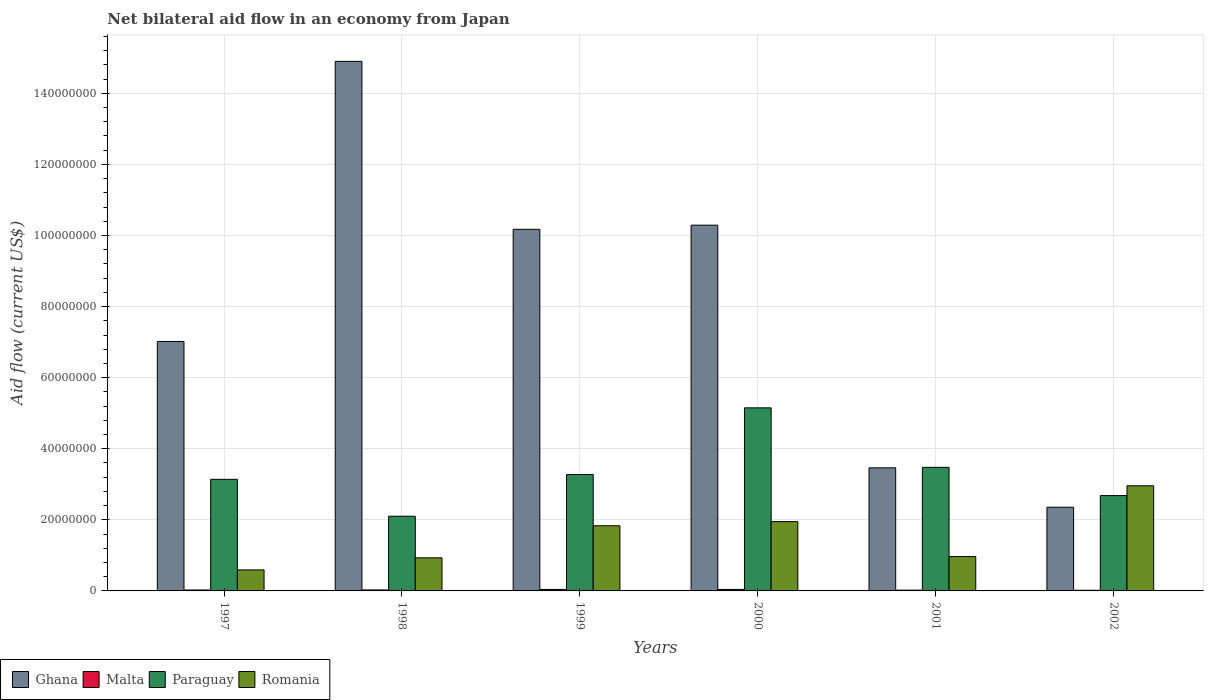How many groups of bars are there?
Offer a very short reply. 6. Are the number of bars per tick equal to the number of legend labels?
Ensure brevity in your answer.  Yes. How many bars are there on the 5th tick from the left?
Give a very brief answer. 4. How many bars are there on the 6th tick from the right?
Give a very brief answer. 4. In how many cases, is the number of bars for a given year not equal to the number of legend labels?
Ensure brevity in your answer.  0. What is the net bilateral aid flow in Paraguay in 2001?
Provide a short and direct response. 3.48e+07. Across all years, what is the maximum net bilateral aid flow in Romania?
Ensure brevity in your answer.  2.96e+07. Across all years, what is the minimum net bilateral aid flow in Ghana?
Ensure brevity in your answer.  2.36e+07. What is the total net bilateral aid flow in Romania in the graph?
Offer a very short reply. 9.23e+07. What is the difference between the net bilateral aid flow in Romania in 1999 and that in 2002?
Ensure brevity in your answer.  -1.12e+07. What is the difference between the net bilateral aid flow in Malta in 1998 and the net bilateral aid flow in Paraguay in 1997?
Give a very brief answer. -3.11e+07. What is the average net bilateral aid flow in Malta per year?
Provide a succinct answer. 2.97e+05. In the year 1997, what is the difference between the net bilateral aid flow in Romania and net bilateral aid flow in Malta?
Offer a very short reply. 5.65e+06. In how many years, is the net bilateral aid flow in Paraguay greater than 152000000 US$?
Offer a very short reply. 0. What is the ratio of the net bilateral aid flow in Romania in 1997 to that in 2000?
Provide a succinct answer. 0.3. Is the difference between the net bilateral aid flow in Romania in 1997 and 1998 greater than the difference between the net bilateral aid flow in Malta in 1997 and 1998?
Provide a short and direct response. No. What is the difference between the highest and the second highest net bilateral aid flow in Romania?
Make the answer very short. 1.01e+07. What is the difference between the highest and the lowest net bilateral aid flow in Romania?
Your answer should be compact. 2.37e+07. Is it the case that in every year, the sum of the net bilateral aid flow in Malta and net bilateral aid flow in Paraguay is greater than the sum of net bilateral aid flow in Romania and net bilateral aid flow in Ghana?
Keep it short and to the point. Yes. What does the 4th bar from the left in 2002 represents?
Your answer should be very brief. Romania. How many bars are there?
Provide a short and direct response. 24. Are all the bars in the graph horizontal?
Your answer should be compact. No. How many years are there in the graph?
Make the answer very short. 6. Are the values on the major ticks of Y-axis written in scientific E-notation?
Offer a very short reply. No. Does the graph contain any zero values?
Your answer should be very brief. No. Does the graph contain grids?
Make the answer very short. Yes. How many legend labels are there?
Offer a very short reply. 4. What is the title of the graph?
Offer a terse response. Net bilateral aid flow in an economy from Japan. Does "OECD members" appear as one of the legend labels in the graph?
Ensure brevity in your answer.  No. What is the label or title of the Y-axis?
Your answer should be very brief. Aid flow (current US$). What is the Aid flow (current US$) of Ghana in 1997?
Your response must be concise. 7.02e+07. What is the Aid flow (current US$) in Malta in 1997?
Your response must be concise. 2.60e+05. What is the Aid flow (current US$) of Paraguay in 1997?
Make the answer very short. 3.14e+07. What is the Aid flow (current US$) of Romania in 1997?
Ensure brevity in your answer.  5.91e+06. What is the Aid flow (current US$) of Ghana in 1998?
Ensure brevity in your answer.  1.49e+08. What is the Aid flow (current US$) of Paraguay in 1998?
Keep it short and to the point. 2.10e+07. What is the Aid flow (current US$) in Romania in 1998?
Offer a very short reply. 9.31e+06. What is the Aid flow (current US$) in Ghana in 1999?
Make the answer very short. 1.02e+08. What is the Aid flow (current US$) of Paraguay in 1999?
Provide a succinct answer. 3.28e+07. What is the Aid flow (current US$) of Romania in 1999?
Your response must be concise. 1.83e+07. What is the Aid flow (current US$) of Ghana in 2000?
Ensure brevity in your answer.  1.03e+08. What is the Aid flow (current US$) in Malta in 2000?
Give a very brief answer. 4.20e+05. What is the Aid flow (current US$) of Paraguay in 2000?
Your answer should be compact. 5.15e+07. What is the Aid flow (current US$) of Romania in 2000?
Provide a succinct answer. 1.95e+07. What is the Aid flow (current US$) of Ghana in 2001?
Keep it short and to the point. 3.46e+07. What is the Aid flow (current US$) of Paraguay in 2001?
Your response must be concise. 3.48e+07. What is the Aid flow (current US$) in Romania in 2001?
Provide a succinct answer. 9.67e+06. What is the Aid flow (current US$) of Ghana in 2002?
Offer a very short reply. 2.36e+07. What is the Aid flow (current US$) of Malta in 2002?
Provide a succinct answer. 1.80e+05. What is the Aid flow (current US$) in Paraguay in 2002?
Give a very brief answer. 2.68e+07. What is the Aid flow (current US$) of Romania in 2002?
Provide a succinct answer. 2.96e+07. Across all years, what is the maximum Aid flow (current US$) in Ghana?
Provide a short and direct response. 1.49e+08. Across all years, what is the maximum Aid flow (current US$) of Malta?
Your response must be concise. 4.20e+05. Across all years, what is the maximum Aid flow (current US$) in Paraguay?
Keep it short and to the point. 5.15e+07. Across all years, what is the maximum Aid flow (current US$) of Romania?
Provide a succinct answer. 2.96e+07. Across all years, what is the minimum Aid flow (current US$) in Ghana?
Your answer should be very brief. 2.36e+07. Across all years, what is the minimum Aid flow (current US$) of Malta?
Make the answer very short. 1.80e+05. Across all years, what is the minimum Aid flow (current US$) in Paraguay?
Offer a very short reply. 2.10e+07. Across all years, what is the minimum Aid flow (current US$) of Romania?
Your answer should be very brief. 5.91e+06. What is the total Aid flow (current US$) in Ghana in the graph?
Your answer should be compact. 4.82e+08. What is the total Aid flow (current US$) of Malta in the graph?
Make the answer very short. 1.78e+06. What is the total Aid flow (current US$) in Paraguay in the graph?
Ensure brevity in your answer.  1.98e+08. What is the total Aid flow (current US$) of Romania in the graph?
Provide a succinct answer. 9.23e+07. What is the difference between the Aid flow (current US$) of Ghana in 1997 and that in 1998?
Offer a terse response. -7.88e+07. What is the difference between the Aid flow (current US$) in Paraguay in 1997 and that in 1998?
Offer a terse response. 1.04e+07. What is the difference between the Aid flow (current US$) in Romania in 1997 and that in 1998?
Give a very brief answer. -3.40e+06. What is the difference between the Aid flow (current US$) in Ghana in 1997 and that in 1999?
Your response must be concise. -3.16e+07. What is the difference between the Aid flow (current US$) of Malta in 1997 and that in 1999?
Give a very brief answer. -1.60e+05. What is the difference between the Aid flow (current US$) in Paraguay in 1997 and that in 1999?
Make the answer very short. -1.36e+06. What is the difference between the Aid flow (current US$) in Romania in 1997 and that in 1999?
Keep it short and to the point. -1.24e+07. What is the difference between the Aid flow (current US$) of Ghana in 1997 and that in 2000?
Give a very brief answer. -3.27e+07. What is the difference between the Aid flow (current US$) of Malta in 1997 and that in 2000?
Your answer should be compact. -1.60e+05. What is the difference between the Aid flow (current US$) of Paraguay in 1997 and that in 2000?
Your answer should be compact. -2.01e+07. What is the difference between the Aid flow (current US$) in Romania in 1997 and that in 2000?
Offer a very short reply. -1.36e+07. What is the difference between the Aid flow (current US$) in Ghana in 1997 and that in 2001?
Your answer should be very brief. 3.56e+07. What is the difference between the Aid flow (current US$) in Paraguay in 1997 and that in 2001?
Provide a short and direct response. -3.37e+06. What is the difference between the Aid flow (current US$) of Romania in 1997 and that in 2001?
Your answer should be compact. -3.76e+06. What is the difference between the Aid flow (current US$) of Ghana in 1997 and that in 2002?
Offer a very short reply. 4.66e+07. What is the difference between the Aid flow (current US$) in Malta in 1997 and that in 2002?
Provide a succinct answer. 8.00e+04. What is the difference between the Aid flow (current US$) of Paraguay in 1997 and that in 2002?
Provide a succinct answer. 4.58e+06. What is the difference between the Aid flow (current US$) in Romania in 1997 and that in 2002?
Keep it short and to the point. -2.37e+07. What is the difference between the Aid flow (current US$) of Ghana in 1998 and that in 1999?
Offer a terse response. 4.72e+07. What is the difference between the Aid flow (current US$) in Malta in 1998 and that in 1999?
Ensure brevity in your answer.  -1.40e+05. What is the difference between the Aid flow (current US$) in Paraguay in 1998 and that in 1999?
Your response must be concise. -1.17e+07. What is the difference between the Aid flow (current US$) in Romania in 1998 and that in 1999?
Provide a succinct answer. -9.03e+06. What is the difference between the Aid flow (current US$) in Ghana in 1998 and that in 2000?
Offer a terse response. 4.61e+07. What is the difference between the Aid flow (current US$) of Malta in 1998 and that in 2000?
Keep it short and to the point. -1.40e+05. What is the difference between the Aid flow (current US$) in Paraguay in 1998 and that in 2000?
Your response must be concise. -3.05e+07. What is the difference between the Aid flow (current US$) of Romania in 1998 and that in 2000?
Provide a short and direct response. -1.02e+07. What is the difference between the Aid flow (current US$) of Ghana in 1998 and that in 2001?
Ensure brevity in your answer.  1.14e+08. What is the difference between the Aid flow (current US$) in Malta in 1998 and that in 2001?
Ensure brevity in your answer.  6.00e+04. What is the difference between the Aid flow (current US$) of Paraguay in 1998 and that in 2001?
Give a very brief answer. -1.38e+07. What is the difference between the Aid flow (current US$) of Romania in 1998 and that in 2001?
Your answer should be very brief. -3.60e+05. What is the difference between the Aid flow (current US$) in Ghana in 1998 and that in 2002?
Your answer should be compact. 1.25e+08. What is the difference between the Aid flow (current US$) of Malta in 1998 and that in 2002?
Offer a terse response. 1.00e+05. What is the difference between the Aid flow (current US$) in Paraguay in 1998 and that in 2002?
Ensure brevity in your answer.  -5.80e+06. What is the difference between the Aid flow (current US$) of Romania in 1998 and that in 2002?
Make the answer very short. -2.03e+07. What is the difference between the Aid flow (current US$) of Ghana in 1999 and that in 2000?
Your response must be concise. -1.16e+06. What is the difference between the Aid flow (current US$) in Malta in 1999 and that in 2000?
Ensure brevity in your answer.  0. What is the difference between the Aid flow (current US$) of Paraguay in 1999 and that in 2000?
Offer a terse response. -1.88e+07. What is the difference between the Aid flow (current US$) in Romania in 1999 and that in 2000?
Your answer should be compact. -1.16e+06. What is the difference between the Aid flow (current US$) of Ghana in 1999 and that in 2001?
Provide a succinct answer. 6.71e+07. What is the difference between the Aid flow (current US$) of Malta in 1999 and that in 2001?
Offer a very short reply. 2.00e+05. What is the difference between the Aid flow (current US$) of Paraguay in 1999 and that in 2001?
Make the answer very short. -2.01e+06. What is the difference between the Aid flow (current US$) of Romania in 1999 and that in 2001?
Give a very brief answer. 8.67e+06. What is the difference between the Aid flow (current US$) of Ghana in 1999 and that in 2002?
Provide a short and direct response. 7.82e+07. What is the difference between the Aid flow (current US$) in Paraguay in 1999 and that in 2002?
Your answer should be compact. 5.94e+06. What is the difference between the Aid flow (current US$) of Romania in 1999 and that in 2002?
Your answer should be very brief. -1.12e+07. What is the difference between the Aid flow (current US$) of Ghana in 2000 and that in 2001?
Ensure brevity in your answer.  6.83e+07. What is the difference between the Aid flow (current US$) of Paraguay in 2000 and that in 2001?
Keep it short and to the point. 1.67e+07. What is the difference between the Aid flow (current US$) in Romania in 2000 and that in 2001?
Offer a very short reply. 9.83e+06. What is the difference between the Aid flow (current US$) in Ghana in 2000 and that in 2002?
Keep it short and to the point. 7.94e+07. What is the difference between the Aid flow (current US$) of Paraguay in 2000 and that in 2002?
Offer a very short reply. 2.47e+07. What is the difference between the Aid flow (current US$) of Romania in 2000 and that in 2002?
Give a very brief answer. -1.01e+07. What is the difference between the Aid flow (current US$) of Ghana in 2001 and that in 2002?
Your answer should be compact. 1.11e+07. What is the difference between the Aid flow (current US$) in Paraguay in 2001 and that in 2002?
Your answer should be very brief. 7.95e+06. What is the difference between the Aid flow (current US$) of Romania in 2001 and that in 2002?
Offer a very short reply. -1.99e+07. What is the difference between the Aid flow (current US$) of Ghana in 1997 and the Aid flow (current US$) of Malta in 1998?
Provide a short and direct response. 6.99e+07. What is the difference between the Aid flow (current US$) in Ghana in 1997 and the Aid flow (current US$) in Paraguay in 1998?
Give a very brief answer. 4.92e+07. What is the difference between the Aid flow (current US$) of Ghana in 1997 and the Aid flow (current US$) of Romania in 1998?
Make the answer very short. 6.09e+07. What is the difference between the Aid flow (current US$) of Malta in 1997 and the Aid flow (current US$) of Paraguay in 1998?
Make the answer very short. -2.08e+07. What is the difference between the Aid flow (current US$) of Malta in 1997 and the Aid flow (current US$) of Romania in 1998?
Keep it short and to the point. -9.05e+06. What is the difference between the Aid flow (current US$) of Paraguay in 1997 and the Aid flow (current US$) of Romania in 1998?
Your answer should be very brief. 2.21e+07. What is the difference between the Aid flow (current US$) in Ghana in 1997 and the Aid flow (current US$) in Malta in 1999?
Provide a succinct answer. 6.98e+07. What is the difference between the Aid flow (current US$) of Ghana in 1997 and the Aid flow (current US$) of Paraguay in 1999?
Keep it short and to the point. 3.74e+07. What is the difference between the Aid flow (current US$) in Ghana in 1997 and the Aid flow (current US$) in Romania in 1999?
Give a very brief answer. 5.18e+07. What is the difference between the Aid flow (current US$) in Malta in 1997 and the Aid flow (current US$) in Paraguay in 1999?
Keep it short and to the point. -3.25e+07. What is the difference between the Aid flow (current US$) of Malta in 1997 and the Aid flow (current US$) of Romania in 1999?
Offer a terse response. -1.81e+07. What is the difference between the Aid flow (current US$) in Paraguay in 1997 and the Aid flow (current US$) in Romania in 1999?
Your answer should be very brief. 1.31e+07. What is the difference between the Aid flow (current US$) in Ghana in 1997 and the Aid flow (current US$) in Malta in 2000?
Provide a succinct answer. 6.98e+07. What is the difference between the Aid flow (current US$) of Ghana in 1997 and the Aid flow (current US$) of Paraguay in 2000?
Your answer should be compact. 1.87e+07. What is the difference between the Aid flow (current US$) in Ghana in 1997 and the Aid flow (current US$) in Romania in 2000?
Your answer should be compact. 5.07e+07. What is the difference between the Aid flow (current US$) in Malta in 1997 and the Aid flow (current US$) in Paraguay in 2000?
Your answer should be compact. -5.12e+07. What is the difference between the Aid flow (current US$) in Malta in 1997 and the Aid flow (current US$) in Romania in 2000?
Keep it short and to the point. -1.92e+07. What is the difference between the Aid flow (current US$) of Paraguay in 1997 and the Aid flow (current US$) of Romania in 2000?
Ensure brevity in your answer.  1.19e+07. What is the difference between the Aid flow (current US$) in Ghana in 1997 and the Aid flow (current US$) in Malta in 2001?
Your answer should be compact. 7.00e+07. What is the difference between the Aid flow (current US$) in Ghana in 1997 and the Aid flow (current US$) in Paraguay in 2001?
Your answer should be compact. 3.54e+07. What is the difference between the Aid flow (current US$) in Ghana in 1997 and the Aid flow (current US$) in Romania in 2001?
Ensure brevity in your answer.  6.05e+07. What is the difference between the Aid flow (current US$) in Malta in 1997 and the Aid flow (current US$) in Paraguay in 2001?
Offer a terse response. -3.45e+07. What is the difference between the Aid flow (current US$) in Malta in 1997 and the Aid flow (current US$) in Romania in 2001?
Give a very brief answer. -9.41e+06. What is the difference between the Aid flow (current US$) of Paraguay in 1997 and the Aid flow (current US$) of Romania in 2001?
Your response must be concise. 2.17e+07. What is the difference between the Aid flow (current US$) of Ghana in 1997 and the Aid flow (current US$) of Malta in 2002?
Your answer should be compact. 7.00e+07. What is the difference between the Aid flow (current US$) of Ghana in 1997 and the Aid flow (current US$) of Paraguay in 2002?
Offer a terse response. 4.34e+07. What is the difference between the Aid flow (current US$) in Ghana in 1997 and the Aid flow (current US$) in Romania in 2002?
Offer a very short reply. 4.06e+07. What is the difference between the Aid flow (current US$) in Malta in 1997 and the Aid flow (current US$) in Paraguay in 2002?
Provide a short and direct response. -2.66e+07. What is the difference between the Aid flow (current US$) of Malta in 1997 and the Aid flow (current US$) of Romania in 2002?
Your response must be concise. -2.93e+07. What is the difference between the Aid flow (current US$) of Paraguay in 1997 and the Aid flow (current US$) of Romania in 2002?
Keep it short and to the point. 1.82e+06. What is the difference between the Aid flow (current US$) in Ghana in 1998 and the Aid flow (current US$) in Malta in 1999?
Your answer should be compact. 1.49e+08. What is the difference between the Aid flow (current US$) of Ghana in 1998 and the Aid flow (current US$) of Paraguay in 1999?
Your response must be concise. 1.16e+08. What is the difference between the Aid flow (current US$) in Ghana in 1998 and the Aid flow (current US$) in Romania in 1999?
Your answer should be very brief. 1.31e+08. What is the difference between the Aid flow (current US$) of Malta in 1998 and the Aid flow (current US$) of Paraguay in 1999?
Give a very brief answer. -3.25e+07. What is the difference between the Aid flow (current US$) in Malta in 1998 and the Aid flow (current US$) in Romania in 1999?
Make the answer very short. -1.81e+07. What is the difference between the Aid flow (current US$) in Paraguay in 1998 and the Aid flow (current US$) in Romania in 1999?
Give a very brief answer. 2.68e+06. What is the difference between the Aid flow (current US$) of Ghana in 1998 and the Aid flow (current US$) of Malta in 2000?
Provide a succinct answer. 1.49e+08. What is the difference between the Aid flow (current US$) in Ghana in 1998 and the Aid flow (current US$) in Paraguay in 2000?
Give a very brief answer. 9.75e+07. What is the difference between the Aid flow (current US$) of Ghana in 1998 and the Aid flow (current US$) of Romania in 2000?
Keep it short and to the point. 1.30e+08. What is the difference between the Aid flow (current US$) of Malta in 1998 and the Aid flow (current US$) of Paraguay in 2000?
Your answer should be very brief. -5.12e+07. What is the difference between the Aid flow (current US$) in Malta in 1998 and the Aid flow (current US$) in Romania in 2000?
Make the answer very short. -1.92e+07. What is the difference between the Aid flow (current US$) in Paraguay in 1998 and the Aid flow (current US$) in Romania in 2000?
Your response must be concise. 1.52e+06. What is the difference between the Aid flow (current US$) in Ghana in 1998 and the Aid flow (current US$) in Malta in 2001?
Your answer should be very brief. 1.49e+08. What is the difference between the Aid flow (current US$) in Ghana in 1998 and the Aid flow (current US$) in Paraguay in 2001?
Your answer should be very brief. 1.14e+08. What is the difference between the Aid flow (current US$) in Ghana in 1998 and the Aid flow (current US$) in Romania in 2001?
Give a very brief answer. 1.39e+08. What is the difference between the Aid flow (current US$) in Malta in 1998 and the Aid flow (current US$) in Paraguay in 2001?
Offer a terse response. -3.45e+07. What is the difference between the Aid flow (current US$) in Malta in 1998 and the Aid flow (current US$) in Romania in 2001?
Your answer should be compact. -9.39e+06. What is the difference between the Aid flow (current US$) in Paraguay in 1998 and the Aid flow (current US$) in Romania in 2001?
Give a very brief answer. 1.14e+07. What is the difference between the Aid flow (current US$) of Ghana in 1998 and the Aid flow (current US$) of Malta in 2002?
Your answer should be compact. 1.49e+08. What is the difference between the Aid flow (current US$) in Ghana in 1998 and the Aid flow (current US$) in Paraguay in 2002?
Provide a short and direct response. 1.22e+08. What is the difference between the Aid flow (current US$) of Ghana in 1998 and the Aid flow (current US$) of Romania in 2002?
Ensure brevity in your answer.  1.19e+08. What is the difference between the Aid flow (current US$) of Malta in 1998 and the Aid flow (current US$) of Paraguay in 2002?
Your answer should be compact. -2.65e+07. What is the difference between the Aid flow (current US$) of Malta in 1998 and the Aid flow (current US$) of Romania in 2002?
Keep it short and to the point. -2.93e+07. What is the difference between the Aid flow (current US$) of Paraguay in 1998 and the Aid flow (current US$) of Romania in 2002?
Your answer should be compact. -8.56e+06. What is the difference between the Aid flow (current US$) in Ghana in 1999 and the Aid flow (current US$) in Malta in 2000?
Offer a terse response. 1.01e+08. What is the difference between the Aid flow (current US$) in Ghana in 1999 and the Aid flow (current US$) in Paraguay in 2000?
Provide a short and direct response. 5.02e+07. What is the difference between the Aid flow (current US$) in Ghana in 1999 and the Aid flow (current US$) in Romania in 2000?
Give a very brief answer. 8.22e+07. What is the difference between the Aid flow (current US$) in Malta in 1999 and the Aid flow (current US$) in Paraguay in 2000?
Your response must be concise. -5.11e+07. What is the difference between the Aid flow (current US$) in Malta in 1999 and the Aid flow (current US$) in Romania in 2000?
Give a very brief answer. -1.91e+07. What is the difference between the Aid flow (current US$) of Paraguay in 1999 and the Aid flow (current US$) of Romania in 2000?
Ensure brevity in your answer.  1.33e+07. What is the difference between the Aid flow (current US$) of Ghana in 1999 and the Aid flow (current US$) of Malta in 2001?
Make the answer very short. 1.02e+08. What is the difference between the Aid flow (current US$) in Ghana in 1999 and the Aid flow (current US$) in Paraguay in 2001?
Ensure brevity in your answer.  6.70e+07. What is the difference between the Aid flow (current US$) of Ghana in 1999 and the Aid flow (current US$) of Romania in 2001?
Keep it short and to the point. 9.21e+07. What is the difference between the Aid flow (current US$) of Malta in 1999 and the Aid flow (current US$) of Paraguay in 2001?
Your answer should be compact. -3.44e+07. What is the difference between the Aid flow (current US$) of Malta in 1999 and the Aid flow (current US$) of Romania in 2001?
Give a very brief answer. -9.25e+06. What is the difference between the Aid flow (current US$) of Paraguay in 1999 and the Aid flow (current US$) of Romania in 2001?
Provide a short and direct response. 2.31e+07. What is the difference between the Aid flow (current US$) of Ghana in 1999 and the Aid flow (current US$) of Malta in 2002?
Your response must be concise. 1.02e+08. What is the difference between the Aid flow (current US$) in Ghana in 1999 and the Aid flow (current US$) in Paraguay in 2002?
Offer a very short reply. 7.49e+07. What is the difference between the Aid flow (current US$) in Ghana in 1999 and the Aid flow (current US$) in Romania in 2002?
Offer a very short reply. 7.22e+07. What is the difference between the Aid flow (current US$) in Malta in 1999 and the Aid flow (current US$) in Paraguay in 2002?
Offer a very short reply. -2.64e+07. What is the difference between the Aid flow (current US$) of Malta in 1999 and the Aid flow (current US$) of Romania in 2002?
Offer a terse response. -2.92e+07. What is the difference between the Aid flow (current US$) of Paraguay in 1999 and the Aid flow (current US$) of Romania in 2002?
Your response must be concise. 3.18e+06. What is the difference between the Aid flow (current US$) in Ghana in 2000 and the Aid flow (current US$) in Malta in 2001?
Your answer should be very brief. 1.03e+08. What is the difference between the Aid flow (current US$) in Ghana in 2000 and the Aid flow (current US$) in Paraguay in 2001?
Keep it short and to the point. 6.81e+07. What is the difference between the Aid flow (current US$) of Ghana in 2000 and the Aid flow (current US$) of Romania in 2001?
Ensure brevity in your answer.  9.32e+07. What is the difference between the Aid flow (current US$) in Malta in 2000 and the Aid flow (current US$) in Paraguay in 2001?
Give a very brief answer. -3.44e+07. What is the difference between the Aid flow (current US$) of Malta in 2000 and the Aid flow (current US$) of Romania in 2001?
Your response must be concise. -9.25e+06. What is the difference between the Aid flow (current US$) in Paraguay in 2000 and the Aid flow (current US$) in Romania in 2001?
Ensure brevity in your answer.  4.18e+07. What is the difference between the Aid flow (current US$) in Ghana in 2000 and the Aid flow (current US$) in Malta in 2002?
Ensure brevity in your answer.  1.03e+08. What is the difference between the Aid flow (current US$) in Ghana in 2000 and the Aid flow (current US$) in Paraguay in 2002?
Provide a short and direct response. 7.61e+07. What is the difference between the Aid flow (current US$) of Ghana in 2000 and the Aid flow (current US$) of Romania in 2002?
Offer a terse response. 7.33e+07. What is the difference between the Aid flow (current US$) of Malta in 2000 and the Aid flow (current US$) of Paraguay in 2002?
Provide a succinct answer. -2.64e+07. What is the difference between the Aid flow (current US$) in Malta in 2000 and the Aid flow (current US$) in Romania in 2002?
Give a very brief answer. -2.92e+07. What is the difference between the Aid flow (current US$) of Paraguay in 2000 and the Aid flow (current US$) of Romania in 2002?
Make the answer very short. 2.19e+07. What is the difference between the Aid flow (current US$) in Ghana in 2001 and the Aid flow (current US$) in Malta in 2002?
Ensure brevity in your answer.  3.44e+07. What is the difference between the Aid flow (current US$) in Ghana in 2001 and the Aid flow (current US$) in Paraguay in 2002?
Offer a very short reply. 7.81e+06. What is the difference between the Aid flow (current US$) of Ghana in 2001 and the Aid flow (current US$) of Romania in 2002?
Make the answer very short. 5.05e+06. What is the difference between the Aid flow (current US$) of Malta in 2001 and the Aid flow (current US$) of Paraguay in 2002?
Offer a terse response. -2.66e+07. What is the difference between the Aid flow (current US$) of Malta in 2001 and the Aid flow (current US$) of Romania in 2002?
Your answer should be compact. -2.94e+07. What is the difference between the Aid flow (current US$) in Paraguay in 2001 and the Aid flow (current US$) in Romania in 2002?
Your answer should be compact. 5.19e+06. What is the average Aid flow (current US$) of Ghana per year?
Your answer should be very brief. 8.03e+07. What is the average Aid flow (current US$) in Malta per year?
Your answer should be compact. 2.97e+05. What is the average Aid flow (current US$) in Paraguay per year?
Keep it short and to the point. 3.30e+07. What is the average Aid flow (current US$) in Romania per year?
Make the answer very short. 1.54e+07. In the year 1997, what is the difference between the Aid flow (current US$) in Ghana and Aid flow (current US$) in Malta?
Keep it short and to the point. 6.99e+07. In the year 1997, what is the difference between the Aid flow (current US$) of Ghana and Aid flow (current US$) of Paraguay?
Ensure brevity in your answer.  3.88e+07. In the year 1997, what is the difference between the Aid flow (current US$) of Ghana and Aid flow (current US$) of Romania?
Provide a succinct answer. 6.43e+07. In the year 1997, what is the difference between the Aid flow (current US$) in Malta and Aid flow (current US$) in Paraguay?
Provide a succinct answer. -3.11e+07. In the year 1997, what is the difference between the Aid flow (current US$) of Malta and Aid flow (current US$) of Romania?
Your answer should be very brief. -5.65e+06. In the year 1997, what is the difference between the Aid flow (current US$) of Paraguay and Aid flow (current US$) of Romania?
Keep it short and to the point. 2.55e+07. In the year 1998, what is the difference between the Aid flow (current US$) in Ghana and Aid flow (current US$) in Malta?
Your response must be concise. 1.49e+08. In the year 1998, what is the difference between the Aid flow (current US$) in Ghana and Aid flow (current US$) in Paraguay?
Provide a succinct answer. 1.28e+08. In the year 1998, what is the difference between the Aid flow (current US$) of Ghana and Aid flow (current US$) of Romania?
Keep it short and to the point. 1.40e+08. In the year 1998, what is the difference between the Aid flow (current US$) of Malta and Aid flow (current US$) of Paraguay?
Provide a succinct answer. -2.07e+07. In the year 1998, what is the difference between the Aid flow (current US$) of Malta and Aid flow (current US$) of Romania?
Offer a very short reply. -9.03e+06. In the year 1998, what is the difference between the Aid flow (current US$) of Paraguay and Aid flow (current US$) of Romania?
Give a very brief answer. 1.17e+07. In the year 1999, what is the difference between the Aid flow (current US$) of Ghana and Aid flow (current US$) of Malta?
Make the answer very short. 1.01e+08. In the year 1999, what is the difference between the Aid flow (current US$) in Ghana and Aid flow (current US$) in Paraguay?
Provide a succinct answer. 6.90e+07. In the year 1999, what is the difference between the Aid flow (current US$) in Ghana and Aid flow (current US$) in Romania?
Your answer should be very brief. 8.34e+07. In the year 1999, what is the difference between the Aid flow (current US$) in Malta and Aid flow (current US$) in Paraguay?
Your answer should be very brief. -3.23e+07. In the year 1999, what is the difference between the Aid flow (current US$) in Malta and Aid flow (current US$) in Romania?
Provide a short and direct response. -1.79e+07. In the year 1999, what is the difference between the Aid flow (current US$) in Paraguay and Aid flow (current US$) in Romania?
Provide a succinct answer. 1.44e+07. In the year 2000, what is the difference between the Aid flow (current US$) in Ghana and Aid flow (current US$) in Malta?
Your answer should be compact. 1.02e+08. In the year 2000, what is the difference between the Aid flow (current US$) in Ghana and Aid flow (current US$) in Paraguay?
Offer a terse response. 5.14e+07. In the year 2000, what is the difference between the Aid flow (current US$) of Ghana and Aid flow (current US$) of Romania?
Keep it short and to the point. 8.34e+07. In the year 2000, what is the difference between the Aid flow (current US$) of Malta and Aid flow (current US$) of Paraguay?
Your response must be concise. -5.11e+07. In the year 2000, what is the difference between the Aid flow (current US$) of Malta and Aid flow (current US$) of Romania?
Provide a succinct answer. -1.91e+07. In the year 2000, what is the difference between the Aid flow (current US$) in Paraguay and Aid flow (current US$) in Romania?
Provide a short and direct response. 3.20e+07. In the year 2001, what is the difference between the Aid flow (current US$) of Ghana and Aid flow (current US$) of Malta?
Your answer should be very brief. 3.44e+07. In the year 2001, what is the difference between the Aid flow (current US$) in Ghana and Aid flow (current US$) in Romania?
Your answer should be very brief. 2.50e+07. In the year 2001, what is the difference between the Aid flow (current US$) of Malta and Aid flow (current US$) of Paraguay?
Ensure brevity in your answer.  -3.46e+07. In the year 2001, what is the difference between the Aid flow (current US$) in Malta and Aid flow (current US$) in Romania?
Make the answer very short. -9.45e+06. In the year 2001, what is the difference between the Aid flow (current US$) of Paraguay and Aid flow (current US$) of Romania?
Offer a terse response. 2.51e+07. In the year 2002, what is the difference between the Aid flow (current US$) of Ghana and Aid flow (current US$) of Malta?
Make the answer very short. 2.34e+07. In the year 2002, what is the difference between the Aid flow (current US$) of Ghana and Aid flow (current US$) of Paraguay?
Offer a very short reply. -3.27e+06. In the year 2002, what is the difference between the Aid flow (current US$) of Ghana and Aid flow (current US$) of Romania?
Give a very brief answer. -6.03e+06. In the year 2002, what is the difference between the Aid flow (current US$) in Malta and Aid flow (current US$) in Paraguay?
Your answer should be compact. -2.66e+07. In the year 2002, what is the difference between the Aid flow (current US$) in Malta and Aid flow (current US$) in Romania?
Ensure brevity in your answer.  -2.94e+07. In the year 2002, what is the difference between the Aid flow (current US$) in Paraguay and Aid flow (current US$) in Romania?
Offer a terse response. -2.76e+06. What is the ratio of the Aid flow (current US$) of Ghana in 1997 to that in 1998?
Give a very brief answer. 0.47. What is the ratio of the Aid flow (current US$) of Paraguay in 1997 to that in 1998?
Your answer should be compact. 1.49. What is the ratio of the Aid flow (current US$) of Romania in 1997 to that in 1998?
Make the answer very short. 0.63. What is the ratio of the Aid flow (current US$) of Ghana in 1997 to that in 1999?
Your answer should be very brief. 0.69. What is the ratio of the Aid flow (current US$) of Malta in 1997 to that in 1999?
Your answer should be compact. 0.62. What is the ratio of the Aid flow (current US$) in Paraguay in 1997 to that in 1999?
Keep it short and to the point. 0.96. What is the ratio of the Aid flow (current US$) in Romania in 1997 to that in 1999?
Your answer should be very brief. 0.32. What is the ratio of the Aid flow (current US$) of Ghana in 1997 to that in 2000?
Your answer should be compact. 0.68. What is the ratio of the Aid flow (current US$) in Malta in 1997 to that in 2000?
Your response must be concise. 0.62. What is the ratio of the Aid flow (current US$) in Paraguay in 1997 to that in 2000?
Provide a short and direct response. 0.61. What is the ratio of the Aid flow (current US$) in Romania in 1997 to that in 2000?
Give a very brief answer. 0.3. What is the ratio of the Aid flow (current US$) of Ghana in 1997 to that in 2001?
Give a very brief answer. 2.03. What is the ratio of the Aid flow (current US$) of Malta in 1997 to that in 2001?
Your response must be concise. 1.18. What is the ratio of the Aid flow (current US$) in Paraguay in 1997 to that in 2001?
Your response must be concise. 0.9. What is the ratio of the Aid flow (current US$) in Romania in 1997 to that in 2001?
Ensure brevity in your answer.  0.61. What is the ratio of the Aid flow (current US$) of Ghana in 1997 to that in 2002?
Keep it short and to the point. 2.98. What is the ratio of the Aid flow (current US$) in Malta in 1997 to that in 2002?
Your response must be concise. 1.44. What is the ratio of the Aid flow (current US$) in Paraguay in 1997 to that in 2002?
Provide a succinct answer. 1.17. What is the ratio of the Aid flow (current US$) of Romania in 1997 to that in 2002?
Give a very brief answer. 0.2. What is the ratio of the Aid flow (current US$) of Ghana in 1998 to that in 1999?
Your answer should be very brief. 1.46. What is the ratio of the Aid flow (current US$) of Malta in 1998 to that in 1999?
Your response must be concise. 0.67. What is the ratio of the Aid flow (current US$) in Paraguay in 1998 to that in 1999?
Ensure brevity in your answer.  0.64. What is the ratio of the Aid flow (current US$) in Romania in 1998 to that in 1999?
Give a very brief answer. 0.51. What is the ratio of the Aid flow (current US$) of Ghana in 1998 to that in 2000?
Keep it short and to the point. 1.45. What is the ratio of the Aid flow (current US$) in Paraguay in 1998 to that in 2000?
Give a very brief answer. 0.41. What is the ratio of the Aid flow (current US$) in Romania in 1998 to that in 2000?
Provide a short and direct response. 0.48. What is the ratio of the Aid flow (current US$) in Ghana in 1998 to that in 2001?
Provide a short and direct response. 4.3. What is the ratio of the Aid flow (current US$) of Malta in 1998 to that in 2001?
Your answer should be compact. 1.27. What is the ratio of the Aid flow (current US$) of Paraguay in 1998 to that in 2001?
Give a very brief answer. 0.6. What is the ratio of the Aid flow (current US$) in Romania in 1998 to that in 2001?
Provide a succinct answer. 0.96. What is the ratio of the Aid flow (current US$) in Ghana in 1998 to that in 2002?
Provide a short and direct response. 6.33. What is the ratio of the Aid flow (current US$) in Malta in 1998 to that in 2002?
Keep it short and to the point. 1.56. What is the ratio of the Aid flow (current US$) in Paraguay in 1998 to that in 2002?
Ensure brevity in your answer.  0.78. What is the ratio of the Aid flow (current US$) of Romania in 1998 to that in 2002?
Your answer should be very brief. 0.31. What is the ratio of the Aid flow (current US$) in Ghana in 1999 to that in 2000?
Ensure brevity in your answer.  0.99. What is the ratio of the Aid flow (current US$) of Paraguay in 1999 to that in 2000?
Keep it short and to the point. 0.64. What is the ratio of the Aid flow (current US$) of Romania in 1999 to that in 2000?
Provide a short and direct response. 0.94. What is the ratio of the Aid flow (current US$) in Ghana in 1999 to that in 2001?
Offer a very short reply. 2.94. What is the ratio of the Aid flow (current US$) in Malta in 1999 to that in 2001?
Offer a very short reply. 1.91. What is the ratio of the Aid flow (current US$) of Paraguay in 1999 to that in 2001?
Keep it short and to the point. 0.94. What is the ratio of the Aid flow (current US$) of Romania in 1999 to that in 2001?
Provide a short and direct response. 1.9. What is the ratio of the Aid flow (current US$) of Ghana in 1999 to that in 2002?
Your answer should be compact. 4.32. What is the ratio of the Aid flow (current US$) in Malta in 1999 to that in 2002?
Your answer should be very brief. 2.33. What is the ratio of the Aid flow (current US$) in Paraguay in 1999 to that in 2002?
Offer a very short reply. 1.22. What is the ratio of the Aid flow (current US$) of Romania in 1999 to that in 2002?
Your response must be concise. 0.62. What is the ratio of the Aid flow (current US$) of Ghana in 2000 to that in 2001?
Ensure brevity in your answer.  2.97. What is the ratio of the Aid flow (current US$) in Malta in 2000 to that in 2001?
Provide a succinct answer. 1.91. What is the ratio of the Aid flow (current US$) of Paraguay in 2000 to that in 2001?
Keep it short and to the point. 1.48. What is the ratio of the Aid flow (current US$) in Romania in 2000 to that in 2001?
Provide a short and direct response. 2.02. What is the ratio of the Aid flow (current US$) of Ghana in 2000 to that in 2002?
Keep it short and to the point. 4.37. What is the ratio of the Aid flow (current US$) of Malta in 2000 to that in 2002?
Ensure brevity in your answer.  2.33. What is the ratio of the Aid flow (current US$) in Paraguay in 2000 to that in 2002?
Offer a terse response. 1.92. What is the ratio of the Aid flow (current US$) in Romania in 2000 to that in 2002?
Provide a succinct answer. 0.66. What is the ratio of the Aid flow (current US$) in Ghana in 2001 to that in 2002?
Offer a terse response. 1.47. What is the ratio of the Aid flow (current US$) of Malta in 2001 to that in 2002?
Offer a terse response. 1.22. What is the ratio of the Aid flow (current US$) of Paraguay in 2001 to that in 2002?
Offer a very short reply. 1.3. What is the ratio of the Aid flow (current US$) in Romania in 2001 to that in 2002?
Provide a short and direct response. 0.33. What is the difference between the highest and the second highest Aid flow (current US$) in Ghana?
Your answer should be very brief. 4.61e+07. What is the difference between the highest and the second highest Aid flow (current US$) in Malta?
Offer a very short reply. 0. What is the difference between the highest and the second highest Aid flow (current US$) in Paraguay?
Your answer should be compact. 1.67e+07. What is the difference between the highest and the second highest Aid flow (current US$) of Romania?
Your answer should be very brief. 1.01e+07. What is the difference between the highest and the lowest Aid flow (current US$) in Ghana?
Provide a succinct answer. 1.25e+08. What is the difference between the highest and the lowest Aid flow (current US$) of Malta?
Your answer should be compact. 2.40e+05. What is the difference between the highest and the lowest Aid flow (current US$) in Paraguay?
Your answer should be compact. 3.05e+07. What is the difference between the highest and the lowest Aid flow (current US$) of Romania?
Keep it short and to the point. 2.37e+07. 